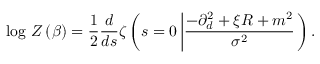Convert formula to latex. <formula><loc_0><loc_0><loc_500><loc_500>\log \, Z \left ( \beta \right ) = \frac { 1 } { 2 } \frac { d } { d s } \zeta \left ( s = 0 \left | \frac { - \partial _ { d } ^ { 2 } + \xi R + m ^ { 2 } } { \sigma ^ { 2 } } \right ) .</formula> 